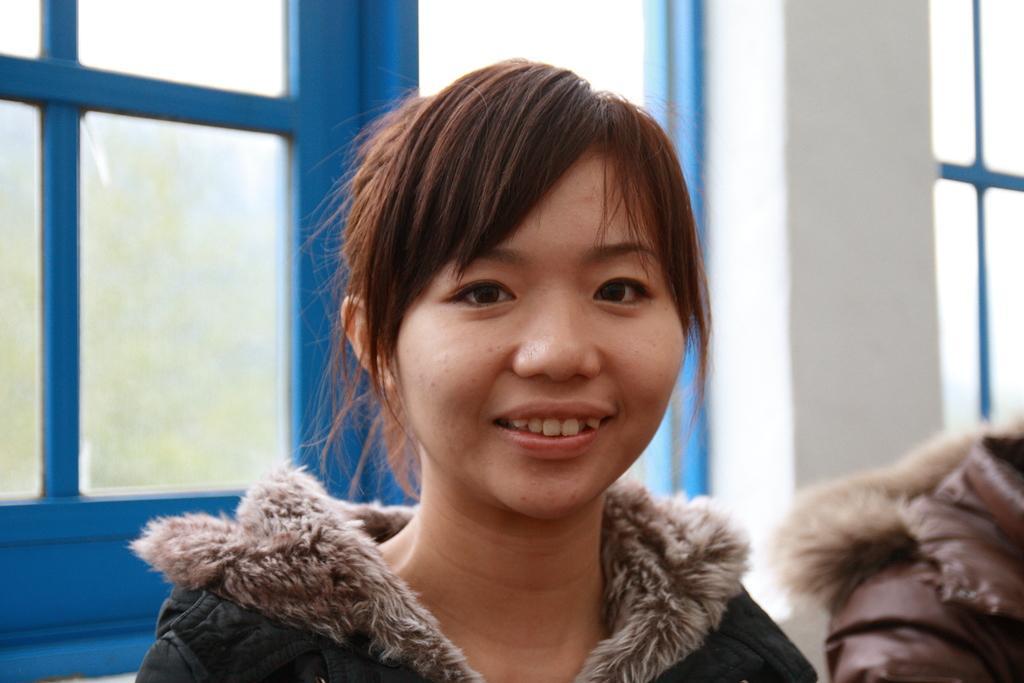Could you give a brief overview of what you see in this image? In this picture we can see a woman here, in the background there is a glass window, we can see a wall here. 